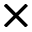Convert formula to latex. <formula><loc_0><loc_0><loc_500><loc_500>\times</formula> 